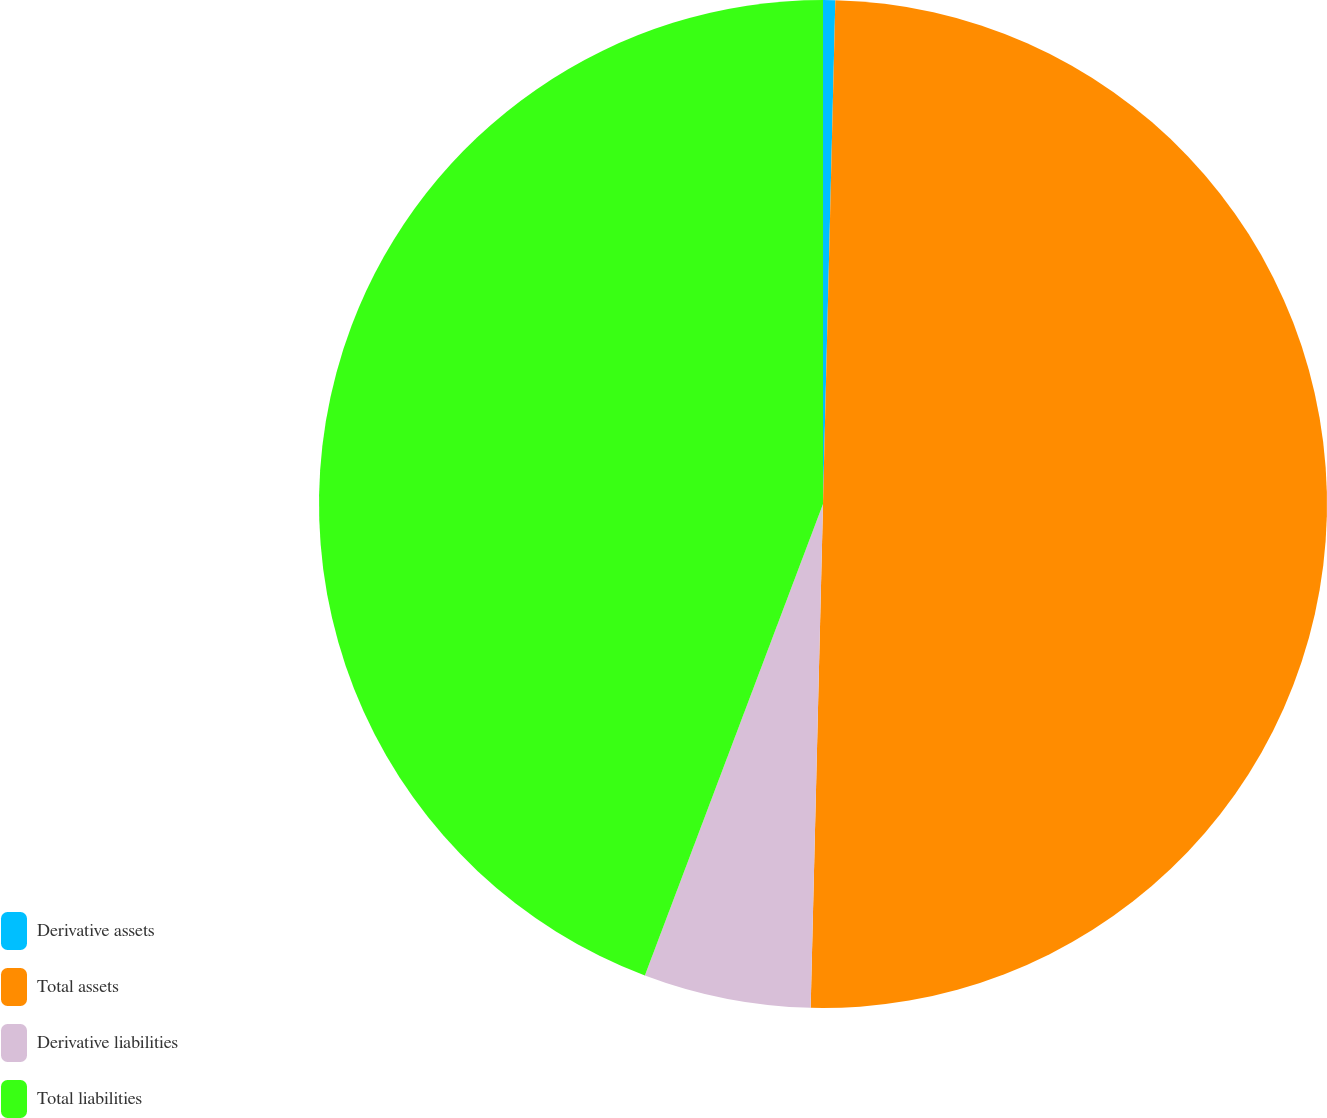Convert chart to OTSL. <chart><loc_0><loc_0><loc_500><loc_500><pie_chart><fcel>Derivative assets<fcel>Total assets<fcel>Derivative liabilities<fcel>Total liabilities<nl><fcel>0.39%<fcel>50.0%<fcel>5.36%<fcel>44.25%<nl></chart> 